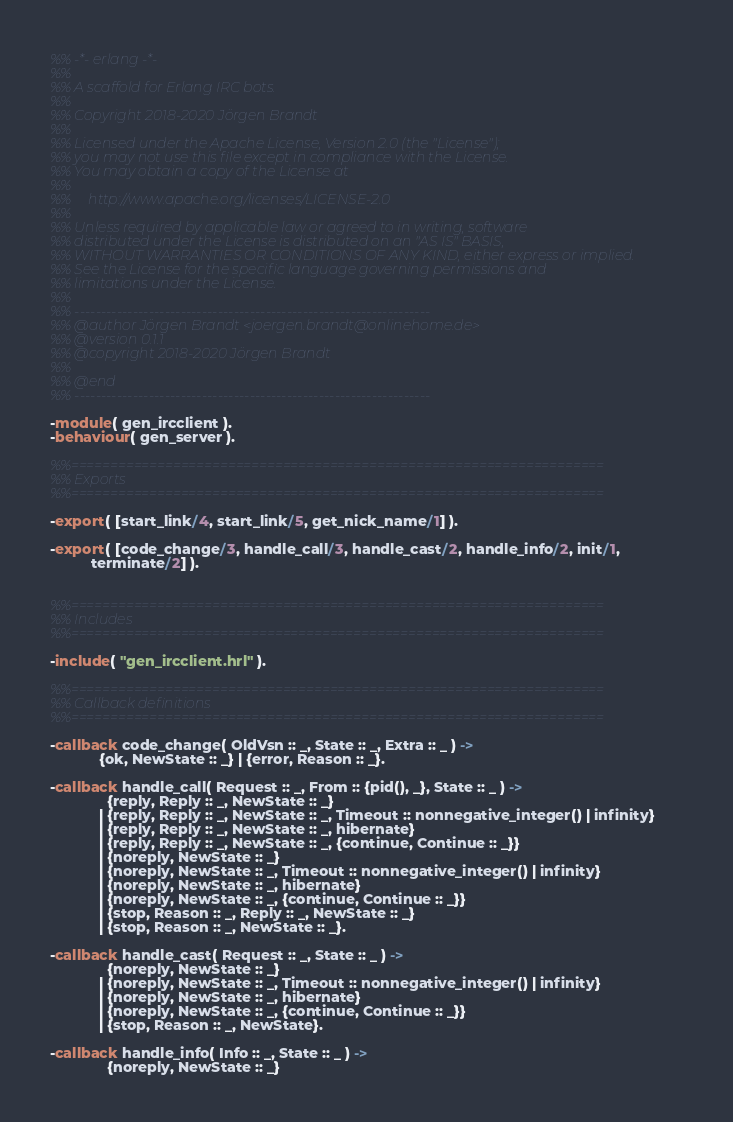<code> <loc_0><loc_0><loc_500><loc_500><_Erlang_>%% -*- erlang -*-
%%
%% A scaffold for Erlang IRC bots.
%%
%% Copyright 2018-2020 Jörgen Brandt
%%
%% Licensed under the Apache License, Version 2.0 (the "License");
%% you may not use this file except in compliance with the License.
%% You may obtain a copy of the License at
%%
%%     http://www.apache.org/licenses/LICENSE-2.0
%%
%% Unless required by applicable law or agreed to in writing, software
%% distributed under the License is distributed on an "AS IS" BASIS,
%% WITHOUT WARRANTIES OR CONDITIONS OF ANY KIND, either express or implied.
%% See the License for the specific language governing permissions and
%% limitations under the License.
%%
%% -------------------------------------------------------------------
%% @author Jörgen Brandt <joergen.brandt@onlinehome.de>
%% @version 0.1.1
%% @copyright 2018-2020 Jörgen Brandt
%%
%% @end
%% -------------------------------------------------------------------

-module( gen_ircclient ).
-behaviour( gen_server ).

%%====================================================================
%% Exports
%%====================================================================

-export( [start_link/4, start_link/5, get_nick_name/1] ).

-export( [code_change/3, handle_call/3, handle_cast/2, handle_info/2, init/1,
          terminate/2] ).


%%====================================================================
%% Includes
%%====================================================================

-include( "gen_ircclient.hrl" ).

%%====================================================================
%% Callback definitions
%%====================================================================

-callback code_change( OldVsn :: _, State :: _, Extra :: _ ) ->
            {ok, NewState :: _} | {error, Reason :: _}.

-callback handle_call( Request :: _, From :: {pid(), _}, State :: _ ) ->
              {reply, Reply :: _, NewState :: _}
            | {reply, Reply :: _, NewState :: _, Timeout :: nonnegative_integer() | infinity}
            | {reply, Reply :: _, NewState :: _, hibernate}
            | {reply, Reply :: _, NewState :: _, {continue, Continue :: _}}
            | {noreply, NewState :: _}
            | {noreply, NewState :: _, Timeout :: nonnegative_integer() | infinity}
            | {noreply, NewState :: _, hibernate}
            | {noreply, NewState :: _, {continue, Continue :: _}}
            | {stop, Reason :: _, Reply :: _, NewState :: _}
            | {stop, Reason :: _, NewState :: _}.

-callback handle_cast( Request :: _, State :: _ ) ->
              {noreply, NewState :: _}
            | {noreply, NewState :: _, Timeout :: nonnegative_integer() | infinity}
            | {noreply, NewState :: _, hibernate}
            | {noreply, NewState :: _, {continue, Continue :: _}}
            | {stop, Reason :: _, NewState}.

-callback handle_info( Info :: _, State :: _ ) ->
              {noreply, NewState :: _}</code> 